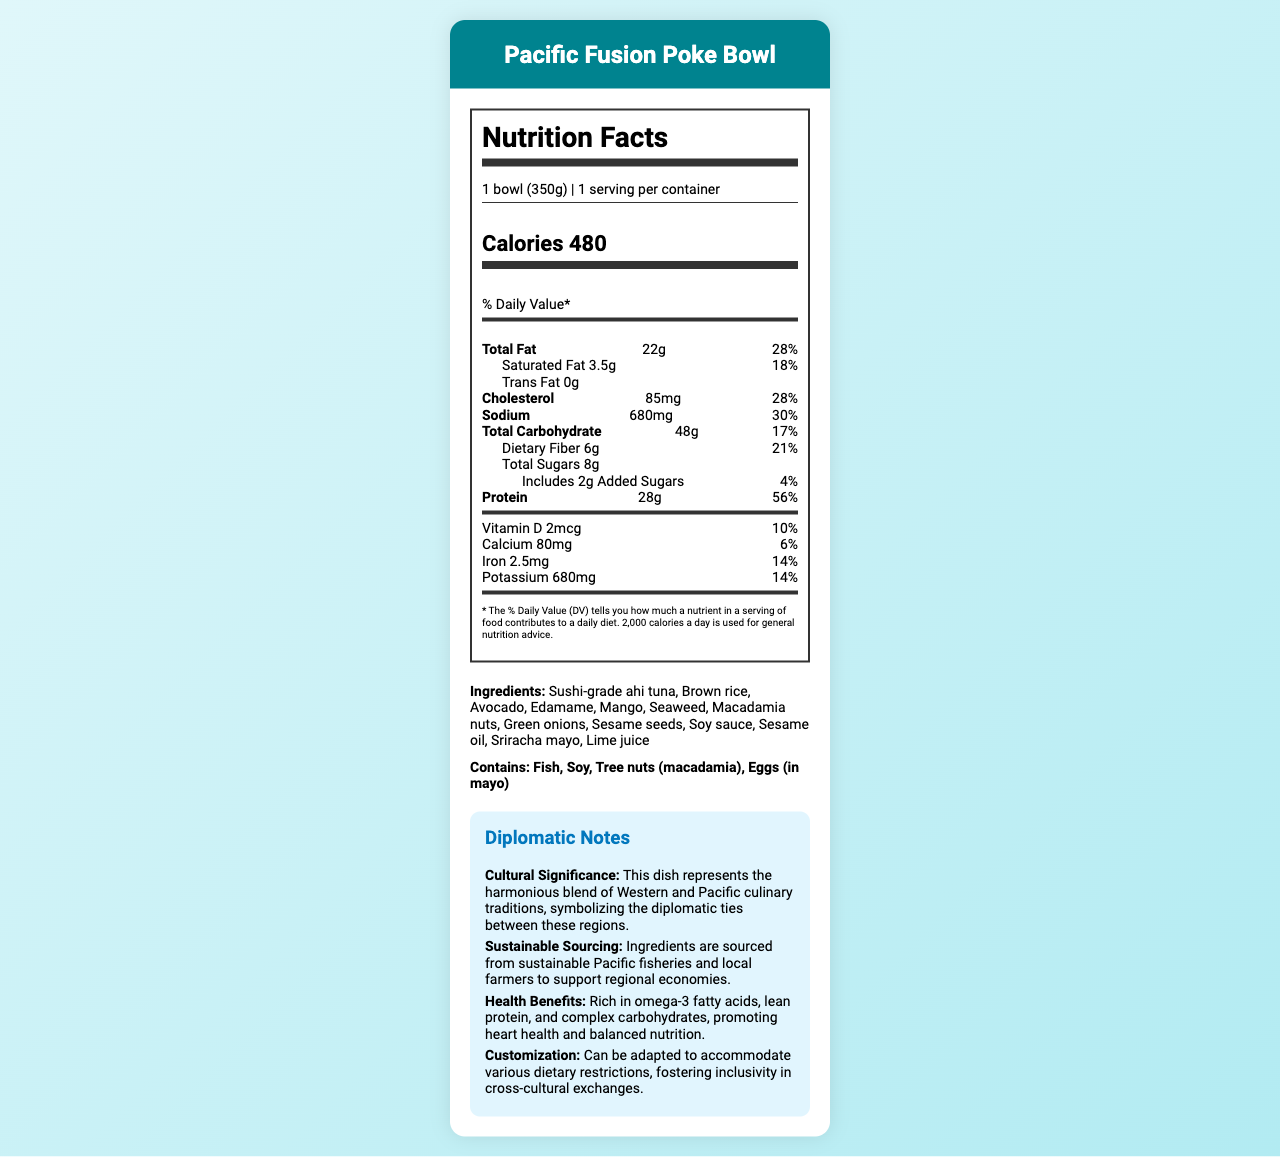what is the serving size for the Pacific Fusion Poke Bowl? The serving size is explicitly mentioned at the top of the Nutrition Facts section.
Answer: 1 bowl (350g) how many calories are in one serving of the Pacific Fusion Poke Bowl? The calories are listed prominently under the "Calories" section.
Answer: 480 how much protein is provided in one serving, and what percentage of the daily value does it represent? The protein content and its percentage of the daily value are clearly stated in the Nutrition Facts section.
Answer: 28g, 56% what are the main ingredients in the Pacific Fusion Poke Bowl? The complete list of ingredients is provided under the "Ingredients" section.
Answer: Sushi-grade ahi tuna, Brown rice, Avocado, Edamame, Mango, Seaweed, Macadamia nuts, Green onions, Sesame seeds, Soy sauce, Sesame oil, Sriracha mayo, Lime juice what allergens are present in the Pacific Fusion Poke Bowl? The allergens are specifically listed in the "Allergens" section.
Answer: Fish, Soy, Tree nuts (macadamia), Eggs (in mayo) what is the total fat content, and how much of it is saturated fat? The total fat and saturated fat content are listed together with their percentages of the daily value.
Answer: 22g of total fat, 3.5g of saturated fat how much dietary fiber does one serving provide? The dietary fiber content is listed under the "Total Carbohydrate" section.
Answer: 6g how much iron is in one serving of the Pacific Fusion Poke Bowl, and what percentage of the daily value does that represent? The iron content and its daily value percentage are provided in the Nutrition Facts.
Answer: 2.5mg, 14% what is the main health benefit mentioned in the diplomatic notes? This is explicitly noted under the "Health Benefits" section of the Diplomatic Notes.
Answer: Promotes heart health and balanced nutrition which nutrients are listed with both their amount and daily value percentage? A. Total Fat, Protein, and Sodium B. Cholesterol, Sodium, and Vitamin D C. Total Carbohydrate, Iron, and Potassium The nutrients that include both amount and daily value percentage are Total Carbohydrate (17%), Iron (14%), and Potassium (14%).
Answer: C which ingredient contains a potential allergen due to "Eggs"? A. Sriracha mayo B. Avocado C. Soy sauce D. Seaweed Sriracha mayo contains eggs, which is noted in the allergens section.
Answer: A does the dish contain any trans fat? The document explicitly states that there is 0g of Trans Fat.
Answer: No can the Pacific Fusion Poke Bowl be adapted to accommodate various dietary restrictions? The Diplomatic Notes section mentions it can be customized to accommodate various dietary restrictions.
Answer: Yes What is the purpose of including the Diplomatic Notes in the document? The Diplomatic Notes add context to the Nutrition Facts by highlighting the dish's symbolic and practical importance.
Answer: The Diplomatic Notes provide insights into the cultural significance, sustainable sourcing, health benefits, and customization options of the Pacific Fusion Poke Bowl, emphasizing its role in cross-cultural exchanges and diplomatic ties. how many added sugars are there in the Pacific Fusion Poke Bowl? The added sugars content is listed under the "Total Carbohydrate" section.
Answer: 2g What amount of calcium is provided, and what percentage of the daily value does it represent? The calcium content and its percentage of the daily value are included in the Nutrition Facts.
Answer: 80mg, 6% how much sodium does one serving of the Pacific Fusion Poke Bowl contain? The sodium content is presented clearly in the Nutrition Facts.
Answer: 680mg what is the reasoning for sustainable sourcing as noted in the Diplomatic Notes? This information is detailed in the "Sustainable Sourcing" section of the Diplomatic Notes.
Answer: Ingredients are sourced from sustainable Pacific fisheries and local farmers to support regional economies. can the exact fishing methods used to source the ahi tuna be determined from the document? The document mentions sustainable sourcing but does not provide specific details on the fishing methods used.
Answer: Not enough information 